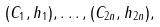Convert formula to latex. <formula><loc_0><loc_0><loc_500><loc_500>( C _ { 1 } , h _ { 1 } ) , \dots , ( C _ { 2 n } , h _ { 2 n } ) ,</formula> 